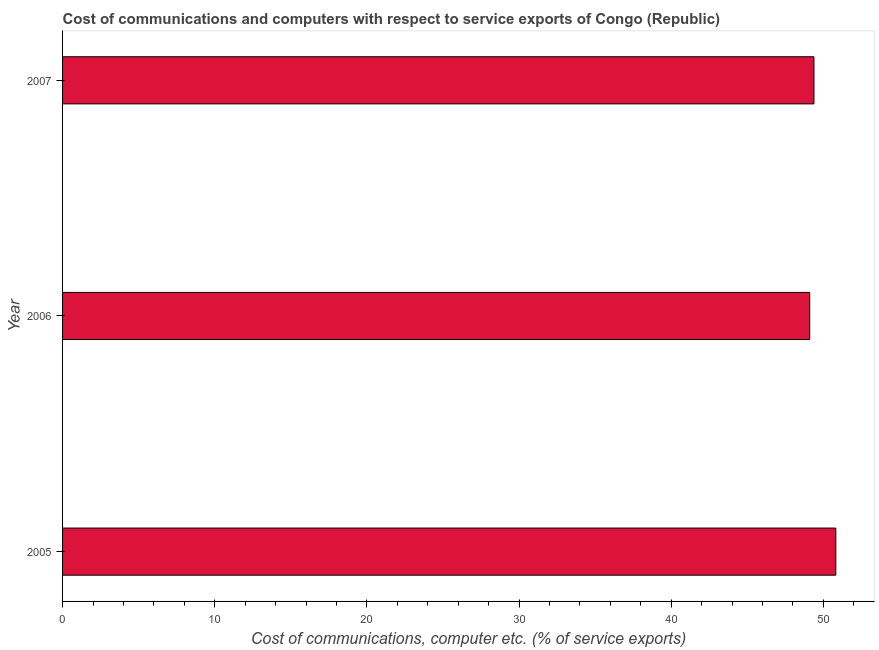Does the graph contain grids?
Keep it short and to the point. No. What is the title of the graph?
Keep it short and to the point. Cost of communications and computers with respect to service exports of Congo (Republic). What is the label or title of the X-axis?
Your response must be concise. Cost of communications, computer etc. (% of service exports). What is the label or title of the Y-axis?
Your response must be concise. Year. What is the cost of communications and computer in 2005?
Ensure brevity in your answer.  50.82. Across all years, what is the maximum cost of communications and computer?
Offer a terse response. 50.82. Across all years, what is the minimum cost of communications and computer?
Give a very brief answer. 49.1. In which year was the cost of communications and computer maximum?
Offer a very short reply. 2005. In which year was the cost of communications and computer minimum?
Offer a very short reply. 2006. What is the sum of the cost of communications and computer?
Give a very brief answer. 149.3. What is the difference between the cost of communications and computer in 2005 and 2006?
Offer a terse response. 1.72. What is the average cost of communications and computer per year?
Keep it short and to the point. 49.77. What is the median cost of communications and computer?
Your answer should be very brief. 49.38. Do a majority of the years between 2007 and 2005 (inclusive) have cost of communications and computer greater than 40 %?
Give a very brief answer. Yes. What is the difference between the highest and the second highest cost of communications and computer?
Ensure brevity in your answer.  1.44. Is the sum of the cost of communications and computer in 2006 and 2007 greater than the maximum cost of communications and computer across all years?
Your response must be concise. Yes. What is the difference between the highest and the lowest cost of communications and computer?
Offer a terse response. 1.72. How many bars are there?
Give a very brief answer. 3. How many years are there in the graph?
Your answer should be very brief. 3. What is the difference between two consecutive major ticks on the X-axis?
Give a very brief answer. 10. Are the values on the major ticks of X-axis written in scientific E-notation?
Ensure brevity in your answer.  No. What is the Cost of communications, computer etc. (% of service exports) in 2005?
Ensure brevity in your answer.  50.82. What is the Cost of communications, computer etc. (% of service exports) of 2006?
Offer a very short reply. 49.1. What is the Cost of communications, computer etc. (% of service exports) of 2007?
Ensure brevity in your answer.  49.38. What is the difference between the Cost of communications, computer etc. (% of service exports) in 2005 and 2006?
Keep it short and to the point. 1.72. What is the difference between the Cost of communications, computer etc. (% of service exports) in 2005 and 2007?
Your answer should be compact. 1.44. What is the difference between the Cost of communications, computer etc. (% of service exports) in 2006 and 2007?
Give a very brief answer. -0.28. What is the ratio of the Cost of communications, computer etc. (% of service exports) in 2005 to that in 2006?
Provide a short and direct response. 1.03. What is the ratio of the Cost of communications, computer etc. (% of service exports) in 2005 to that in 2007?
Offer a very short reply. 1.03. 